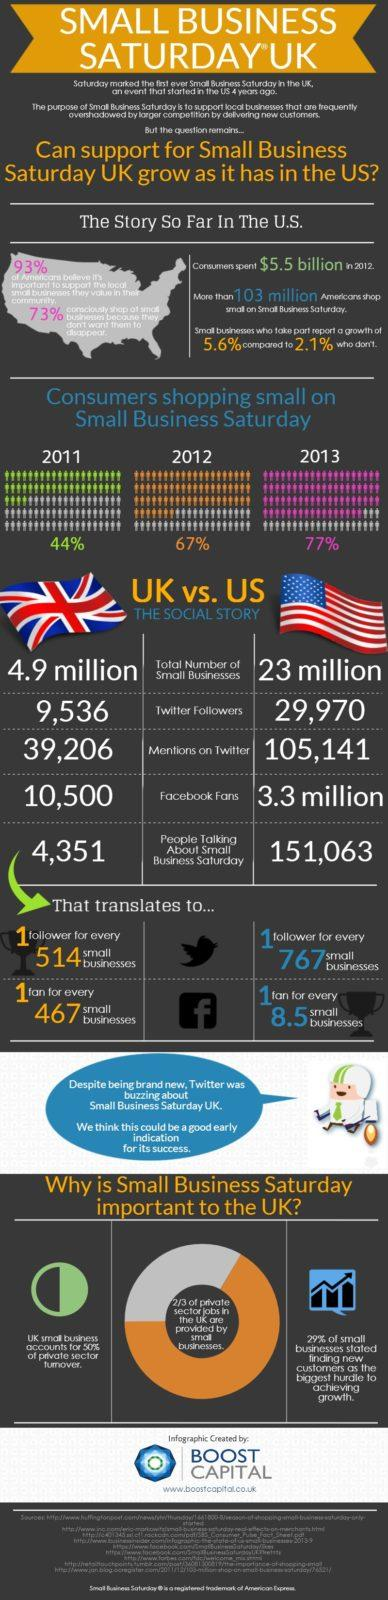Give some essential details in this illustration. Approximately 1 small business in the United States has 1 Twitter follower for every 767 small businesses. According to the data, a total of 39,206 Twitter mentions were received by Small Business Saturday in the UK. In 2013, 77% of consumers participated in Small Business Saturday by shopping at small businesses. According to the number of Facebook fans, there are approximately 3.3 million fans of Small Business Saturday in the US. As of today, there are approximately 9,536 Twitter followers for Small Business Saturday in the UK. 